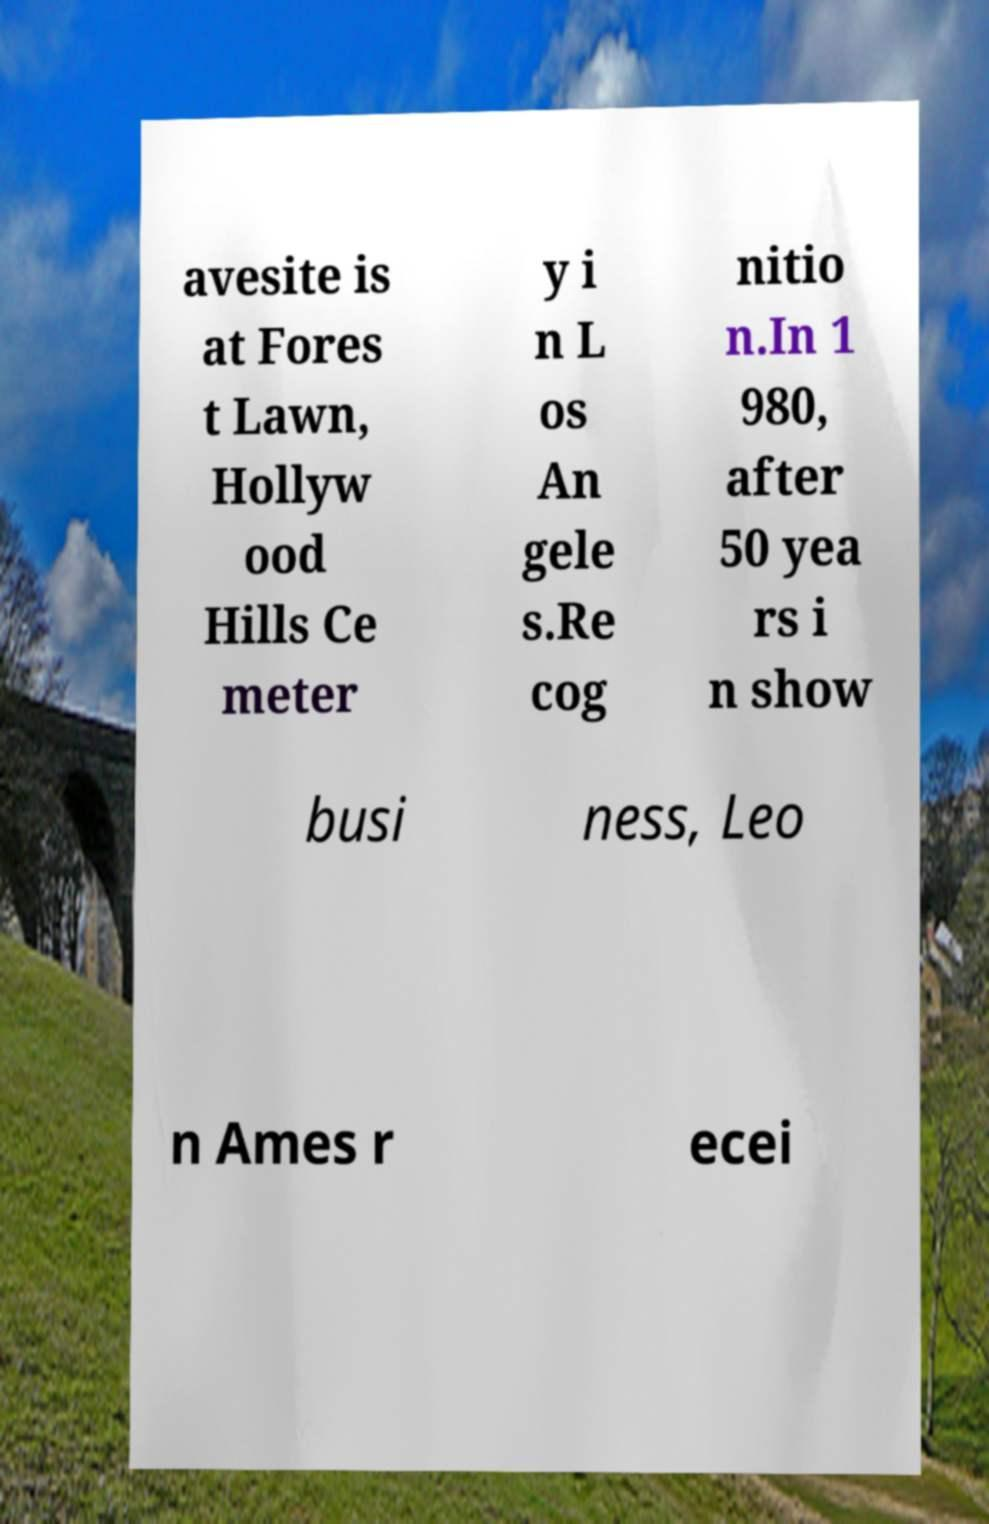I need the written content from this picture converted into text. Can you do that? avesite is at Fores t Lawn, Hollyw ood Hills Ce meter y i n L os An gele s.Re cog nitio n.In 1 980, after 50 yea rs i n show busi ness, Leo n Ames r ecei 